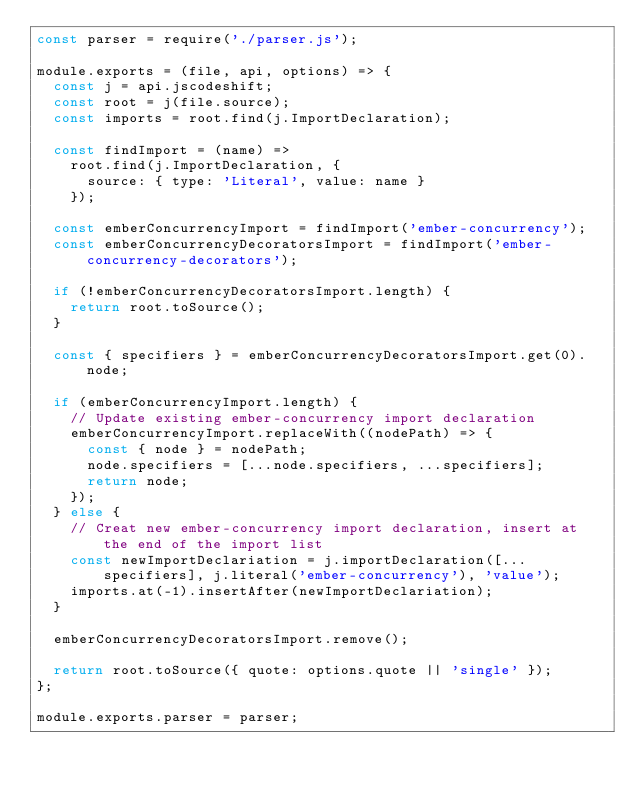<code> <loc_0><loc_0><loc_500><loc_500><_JavaScript_>const parser = require('./parser.js');

module.exports = (file, api, options) => {
  const j = api.jscodeshift;
  const root = j(file.source);
  const imports = root.find(j.ImportDeclaration);

  const findImport = (name) =>
    root.find(j.ImportDeclaration, {
      source: { type: 'Literal', value: name }
    });

  const emberConcurrencyImport = findImport('ember-concurrency');
  const emberConcurrencyDecoratorsImport = findImport('ember-concurrency-decorators');

  if (!emberConcurrencyDecoratorsImport.length) {
    return root.toSource();
  }

  const { specifiers } = emberConcurrencyDecoratorsImport.get(0).node;

  if (emberConcurrencyImport.length) {
    // Update existing ember-concurrency import declaration
    emberConcurrencyImport.replaceWith((nodePath) => {
      const { node } = nodePath;
      node.specifiers = [...node.specifiers, ...specifiers];
      return node;
    });
  } else {
    // Creat new ember-concurrency import declaration, insert at the end of the import list
    const newImportDeclariation = j.importDeclaration([...specifiers], j.literal('ember-concurrency'), 'value');
    imports.at(-1).insertAfter(newImportDeclariation);
  }

  emberConcurrencyDecoratorsImport.remove();

  return root.toSource({ quote: options.quote || 'single' });
};

module.exports.parser = parser;
</code> 